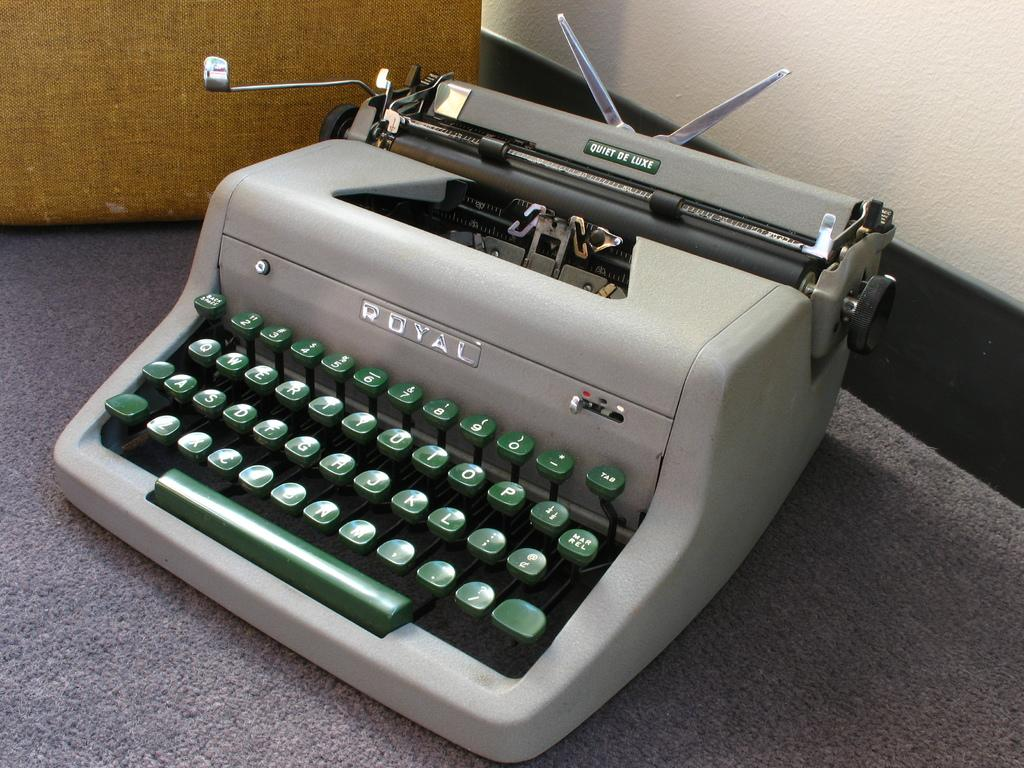Provide a one-sentence caption for the provided image. An old school Royal typewriter that is the Quiet De Luxe model. 